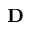Convert formula to latex. <formula><loc_0><loc_0><loc_500><loc_500>D</formula> 